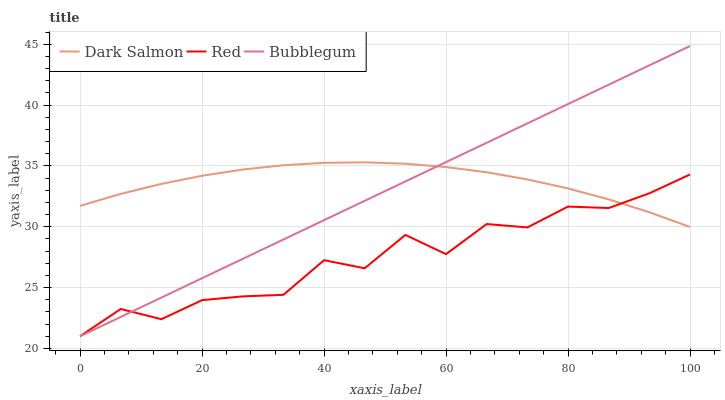Does Red have the minimum area under the curve?
Answer yes or no. Yes. Does Dark Salmon have the maximum area under the curve?
Answer yes or no. Yes. Does Dark Salmon have the minimum area under the curve?
Answer yes or no. No. Does Red have the maximum area under the curve?
Answer yes or no. No. Is Bubblegum the smoothest?
Answer yes or no. Yes. Is Red the roughest?
Answer yes or no. Yes. Is Dark Salmon the smoothest?
Answer yes or no. No. Is Dark Salmon the roughest?
Answer yes or no. No. Does Bubblegum have the lowest value?
Answer yes or no. Yes. Does Dark Salmon have the lowest value?
Answer yes or no. No. Does Bubblegum have the highest value?
Answer yes or no. Yes. Does Dark Salmon have the highest value?
Answer yes or no. No. Does Dark Salmon intersect Red?
Answer yes or no. Yes. Is Dark Salmon less than Red?
Answer yes or no. No. Is Dark Salmon greater than Red?
Answer yes or no. No. 